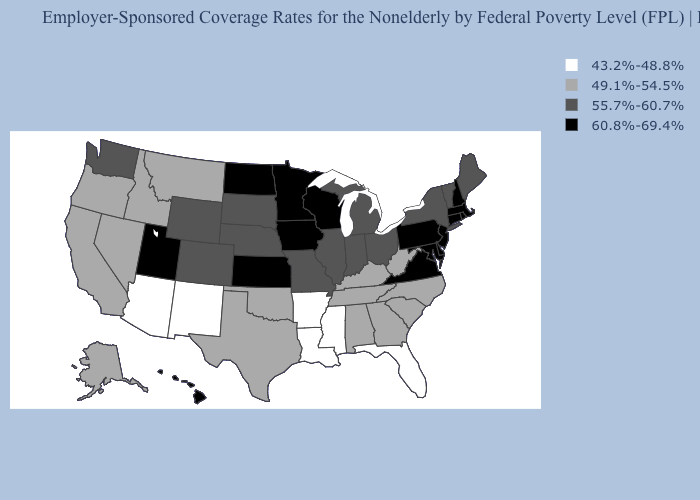What is the value of Wisconsin?
Quick response, please. 60.8%-69.4%. Which states have the lowest value in the MidWest?
Keep it brief. Illinois, Indiana, Michigan, Missouri, Nebraska, Ohio, South Dakota. What is the value of Louisiana?
Give a very brief answer. 43.2%-48.8%. What is the value of Rhode Island?
Answer briefly. 60.8%-69.4%. Name the states that have a value in the range 55.7%-60.7%?
Short answer required. Colorado, Illinois, Indiana, Maine, Michigan, Missouri, Nebraska, New York, Ohio, South Dakota, Vermont, Washington, Wyoming. What is the lowest value in the MidWest?
Quick response, please. 55.7%-60.7%. Does Idaho have the lowest value in the West?
Write a very short answer. No. Which states have the lowest value in the USA?
Answer briefly. Arizona, Arkansas, Florida, Louisiana, Mississippi, New Mexico. What is the lowest value in the USA?
Answer briefly. 43.2%-48.8%. What is the lowest value in the MidWest?
Answer briefly. 55.7%-60.7%. What is the value of Wisconsin?
Give a very brief answer. 60.8%-69.4%. Name the states that have a value in the range 43.2%-48.8%?
Write a very short answer. Arizona, Arkansas, Florida, Louisiana, Mississippi, New Mexico. Name the states that have a value in the range 49.1%-54.5%?
Quick response, please. Alabama, Alaska, California, Georgia, Idaho, Kentucky, Montana, Nevada, North Carolina, Oklahoma, Oregon, South Carolina, Tennessee, Texas, West Virginia. Name the states that have a value in the range 60.8%-69.4%?
Answer briefly. Connecticut, Delaware, Hawaii, Iowa, Kansas, Maryland, Massachusetts, Minnesota, New Hampshire, New Jersey, North Dakota, Pennsylvania, Rhode Island, Utah, Virginia, Wisconsin. Which states have the highest value in the USA?
Quick response, please. Connecticut, Delaware, Hawaii, Iowa, Kansas, Maryland, Massachusetts, Minnesota, New Hampshire, New Jersey, North Dakota, Pennsylvania, Rhode Island, Utah, Virginia, Wisconsin. 